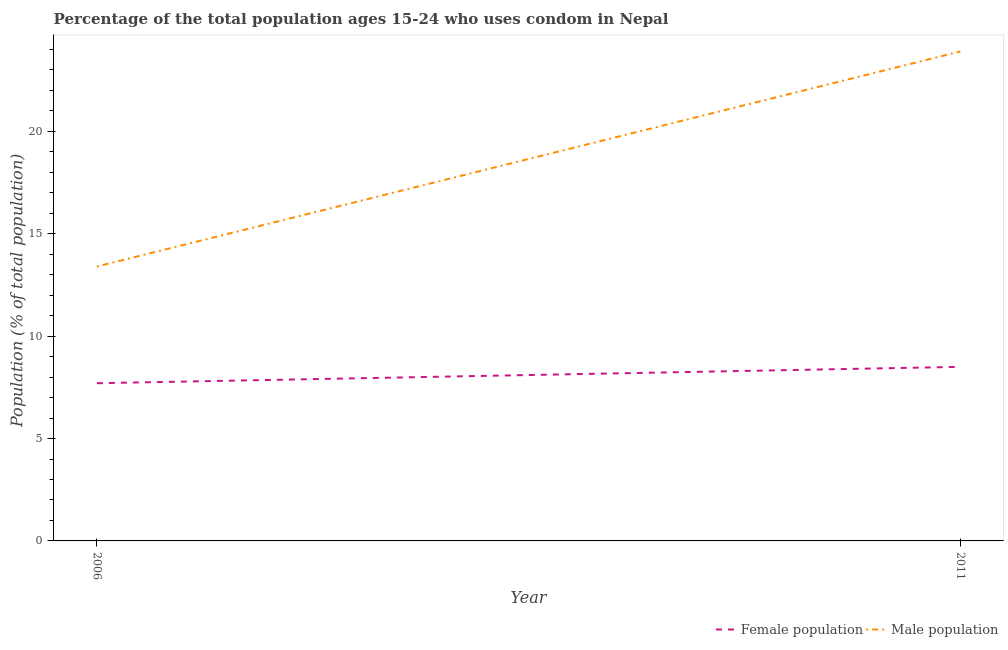How many different coloured lines are there?
Your answer should be compact. 2. Does the line corresponding to female population intersect with the line corresponding to male population?
Your response must be concise. No. Is the number of lines equal to the number of legend labels?
Your answer should be compact. Yes. Across all years, what is the maximum male population?
Offer a terse response. 23.9. What is the total female population in the graph?
Provide a short and direct response. 16.2. What is the difference between the female population in 2006 and that in 2011?
Provide a succinct answer. -0.8. What is the average male population per year?
Your answer should be compact. 18.65. In the year 2011, what is the difference between the female population and male population?
Your answer should be compact. -15.4. In how many years, is the male population greater than 14 %?
Make the answer very short. 1. What is the ratio of the male population in 2006 to that in 2011?
Your answer should be compact. 0.56. In how many years, is the male population greater than the average male population taken over all years?
Offer a very short reply. 1. Does the female population monotonically increase over the years?
Provide a succinct answer. Yes. How many years are there in the graph?
Keep it short and to the point. 2. What is the difference between two consecutive major ticks on the Y-axis?
Your answer should be very brief. 5. How many legend labels are there?
Your answer should be very brief. 2. What is the title of the graph?
Provide a short and direct response. Percentage of the total population ages 15-24 who uses condom in Nepal. What is the label or title of the X-axis?
Give a very brief answer. Year. What is the label or title of the Y-axis?
Make the answer very short. Population (% of total population) . What is the Population (% of total population)  in Female population in 2011?
Your answer should be compact. 8.5. What is the Population (% of total population)  in Male population in 2011?
Provide a short and direct response. 23.9. Across all years, what is the maximum Population (% of total population)  in Male population?
Ensure brevity in your answer.  23.9. Across all years, what is the minimum Population (% of total population)  in Male population?
Your answer should be very brief. 13.4. What is the total Population (% of total population)  in Female population in the graph?
Your answer should be very brief. 16.2. What is the total Population (% of total population)  in Male population in the graph?
Keep it short and to the point. 37.3. What is the difference between the Population (% of total population)  in Female population in 2006 and that in 2011?
Make the answer very short. -0.8. What is the difference between the Population (% of total population)  of Male population in 2006 and that in 2011?
Make the answer very short. -10.5. What is the difference between the Population (% of total population)  of Female population in 2006 and the Population (% of total population)  of Male population in 2011?
Provide a short and direct response. -16.2. What is the average Population (% of total population)  in Male population per year?
Offer a terse response. 18.65. In the year 2006, what is the difference between the Population (% of total population)  of Female population and Population (% of total population)  of Male population?
Ensure brevity in your answer.  -5.7. In the year 2011, what is the difference between the Population (% of total population)  in Female population and Population (% of total population)  in Male population?
Your answer should be very brief. -15.4. What is the ratio of the Population (% of total population)  of Female population in 2006 to that in 2011?
Provide a short and direct response. 0.91. What is the ratio of the Population (% of total population)  of Male population in 2006 to that in 2011?
Your answer should be very brief. 0.56. What is the difference between the highest and the second highest Population (% of total population)  in Female population?
Make the answer very short. 0.8. What is the difference between the highest and the second highest Population (% of total population)  in Male population?
Offer a terse response. 10.5. What is the difference between the highest and the lowest Population (% of total population)  of Female population?
Give a very brief answer. 0.8. 